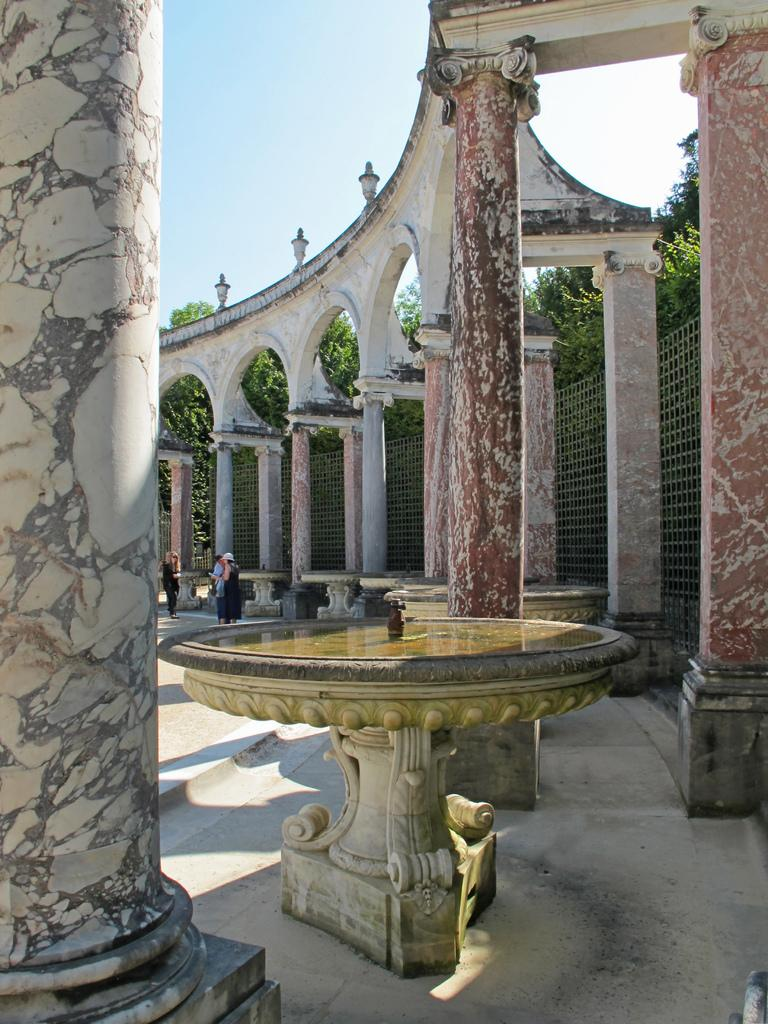What type of architectural elements can be seen in the image? There are many pillars and walls in the image. What is located on the floor in the front of the image? There is a fountain on the floor in the front of the image. What type of vegetation is visible in the background of the image? There are many trees in the background of the image. What is visible at the top of the image? The sky is visible at the top of the image. How many houses are visible in the image? There are no houses visible in the image; it features pillars, walls, a fountain, trees, and the sky. What type of stocking is hanging from the fountain in the image? There is no stocking present in the image; it features a fountain, pillars, walls, trees, and the sky. 